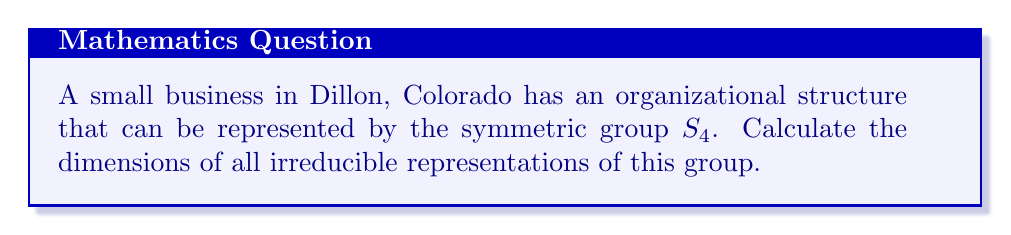Could you help me with this problem? To find the dimensions of irreducible representations for $S_4$, we'll follow these steps:

1) Recall that the number of irreducible representations of a finite group is equal to the number of conjugacy classes. For $S_4$, there are 5 conjugacy classes:
   - (1) : identity
   - (12) : 2-cycles
   - (123) : 3-cycles
   - (1234) : 4-cycles
   - (12)(34) : product of two 2-cycles

2) The sum of squares of dimensions of irreducible representations equals the order of the group. For $S_4$, we have:

   $$d_1^2 + d_2^2 + d_3^2 + d_4^2 + d_5^2 = |S_4| = 4! = 24$$

3) We know that every group has a trivial representation of dimension 1, and $S_4$ has a sign representation of dimension 1. So $d_1 = d_2 = 1$.

4) $S_4$ has a standard representation of dimension $n-1 = 3$.

5) Using the character table of $S_4$, we can determine that there are two more irreducible representations, both of dimension 3.

6) Substituting into the equation from step 2:

   $$1^2 + 1^2 + 3^2 + 3^2 + 3^2 = 24$$

Therefore, the dimensions of the irreducible representations of $S_4$ are 1, 1, 3, 3, and 3.
Answer: 1, 1, 3, 3, 3 